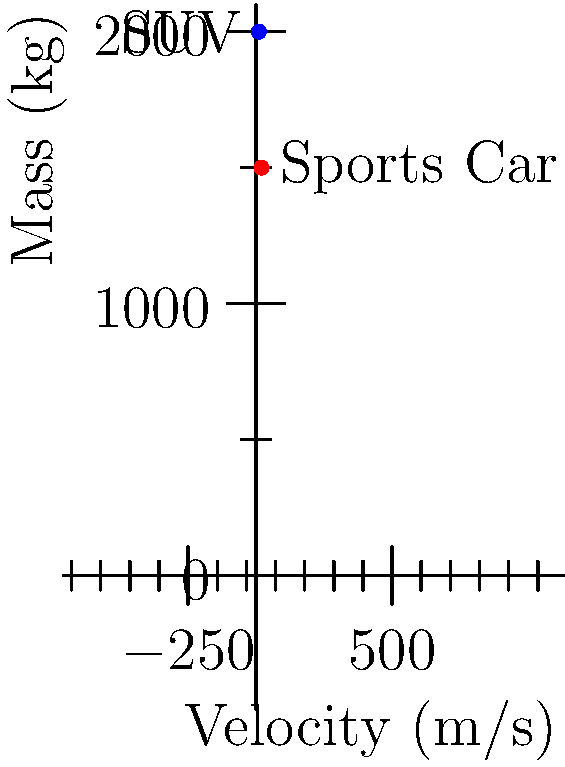In your upcoming action movie, you're planning a dramatic crash scene between a sports car and an SUV. The sports car (mass 1500 kg) is initially moving at 20 m/s, while the SUV (mass 2000 kg) is moving in the opposite direction at 10 m/s. Assuming a perfectly inelastic collision, what will be the final velocity of the combined wreckage immediately after the impact? To solve this problem, we'll use the principle of conservation of momentum. The steps are as follows:

1. Calculate the initial momentum of each vehicle:
   Sports car: $p_1 = m_1v_1 = 1500 \text{ kg} \times 20 \text{ m/s} = 30,000 \text{ kg}\cdot\text{m/s}$
   SUV: $p_2 = m_2v_2 = 2000 \text{ kg} \times (-10 \text{ m/s}) = -20,000 \text{ kg}\cdot\text{m/s}$
   (Note: The SUV's velocity is negative because it's moving in the opposite direction)

2. Calculate the total initial momentum:
   $p_{\text{total}} = p_1 + p_2 = 30,000 + (-20,000) = 10,000 \text{ kg}\cdot\text{m/s}$

3. In a perfectly inelastic collision, the vehicles stick together after impact. The combined mass is:
   $m_{\text{total}} = m_1 + m_2 = 1500 \text{ kg} + 2000 \text{ kg} = 3500 \text{ kg}$

4. Using conservation of momentum, the final momentum equals the initial momentum:
   $p_{\text{final}} = p_{\text{total}} = 10,000 \text{ kg}\cdot\text{m/s}$

5. Calculate the final velocity:
   $v_{\text{final}} = \frac{p_{\text{final}}}{m_{\text{total}}} = \frac{10,000 \text{ kg}\cdot\text{m/s}}{3500 \text{ kg}} \approx 2.86 \text{ m/s}$

Therefore, the combined wreckage will move at approximately 2.86 m/s in the original direction of the sports car immediately after the collision.
Answer: 2.86 m/s in the direction of the sports car's initial motion 